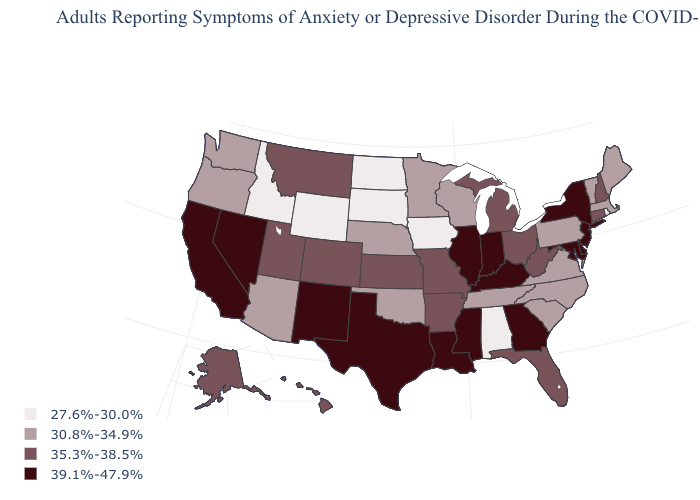What is the value of North Dakota?
Write a very short answer. 27.6%-30.0%. What is the value of Wisconsin?
Keep it brief. 30.8%-34.9%. Among the states that border Oregon , does Idaho have the lowest value?
Concise answer only. Yes. Is the legend a continuous bar?
Answer briefly. No. What is the lowest value in states that border Iowa?
Write a very short answer. 27.6%-30.0%. What is the value of Arkansas?
Short answer required. 35.3%-38.5%. Does the first symbol in the legend represent the smallest category?
Answer briefly. Yes. Name the states that have a value in the range 27.6%-30.0%?
Keep it brief. Alabama, Idaho, Iowa, North Dakota, Rhode Island, South Dakota, Wyoming. What is the lowest value in the South?
Quick response, please. 27.6%-30.0%. What is the value of Pennsylvania?
Short answer required. 30.8%-34.9%. What is the value of Indiana?
Short answer required. 39.1%-47.9%. Among the states that border Arkansas , which have the lowest value?
Give a very brief answer. Oklahoma, Tennessee. Name the states that have a value in the range 30.8%-34.9%?
Keep it brief. Arizona, Maine, Massachusetts, Minnesota, Nebraska, North Carolina, Oklahoma, Oregon, Pennsylvania, South Carolina, Tennessee, Vermont, Virginia, Washington, Wisconsin. Which states have the lowest value in the USA?
Concise answer only. Alabama, Idaho, Iowa, North Dakota, Rhode Island, South Dakota, Wyoming. Does the map have missing data?
Keep it brief. No. 